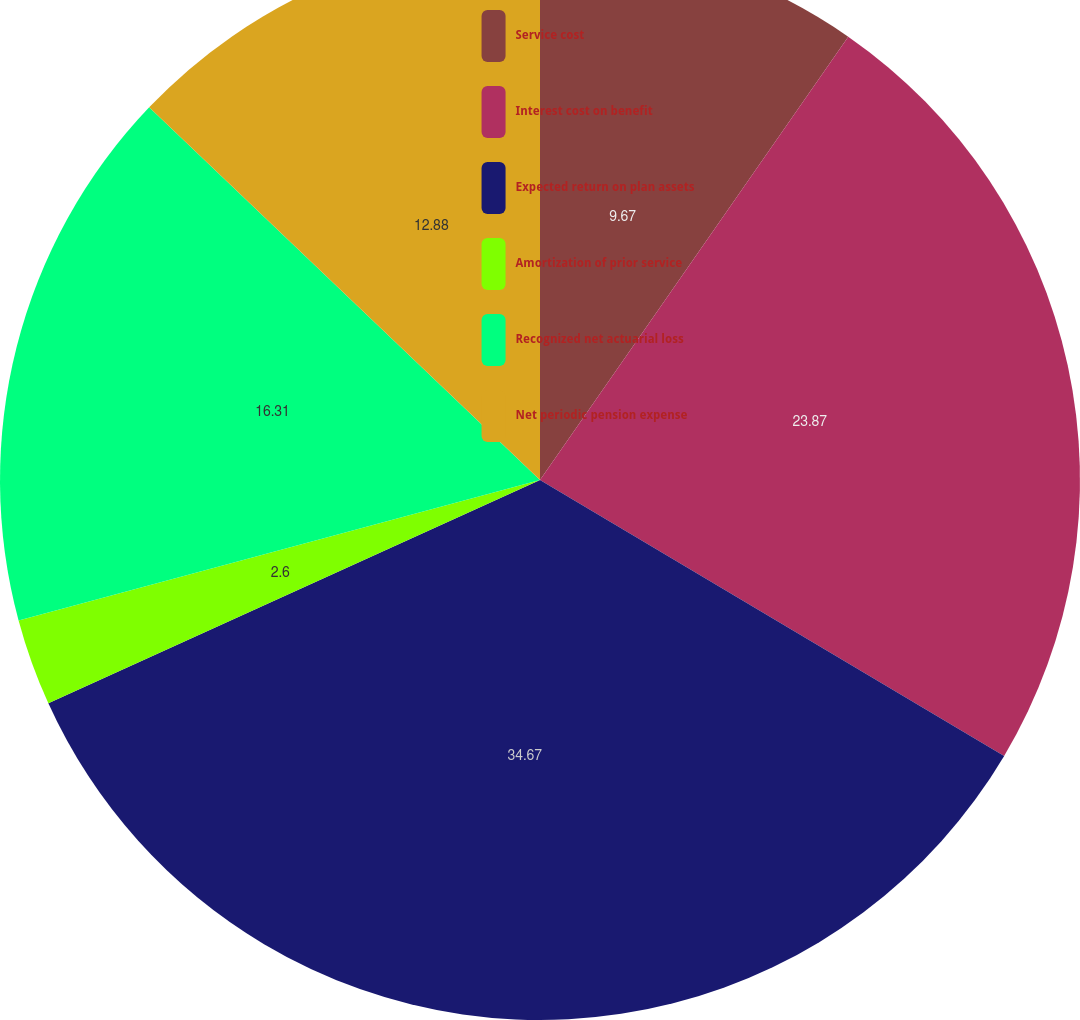Convert chart to OTSL. <chart><loc_0><loc_0><loc_500><loc_500><pie_chart><fcel>Service cost<fcel>Interest cost on benefit<fcel>Expected return on plan assets<fcel>Amortization of prior service<fcel>Recognized net actuarial loss<fcel>Net periodic pension expense<nl><fcel>9.67%<fcel>23.87%<fcel>34.68%<fcel>2.6%<fcel>16.31%<fcel>12.88%<nl></chart> 